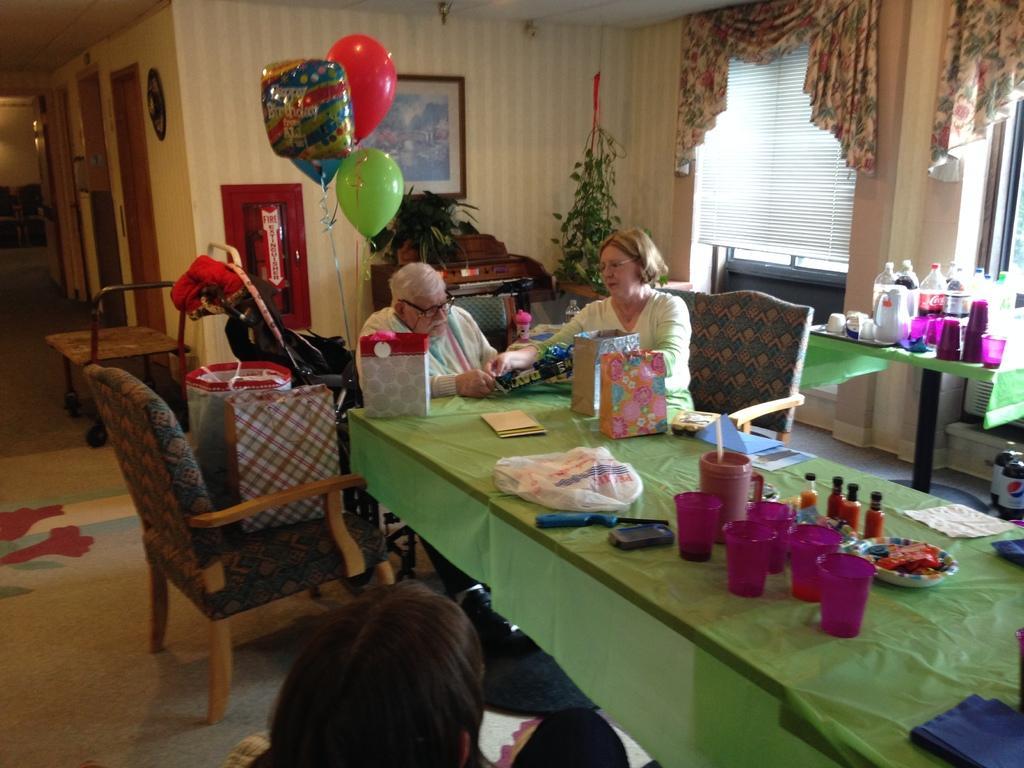Could you give a brief overview of what you see in this image? In the image there is a woman and sat on chair in front of table,the table has many glasses and it seems to be in drawing room,there is window with curtain and a corner there are plants,beside the women there are balloons. 